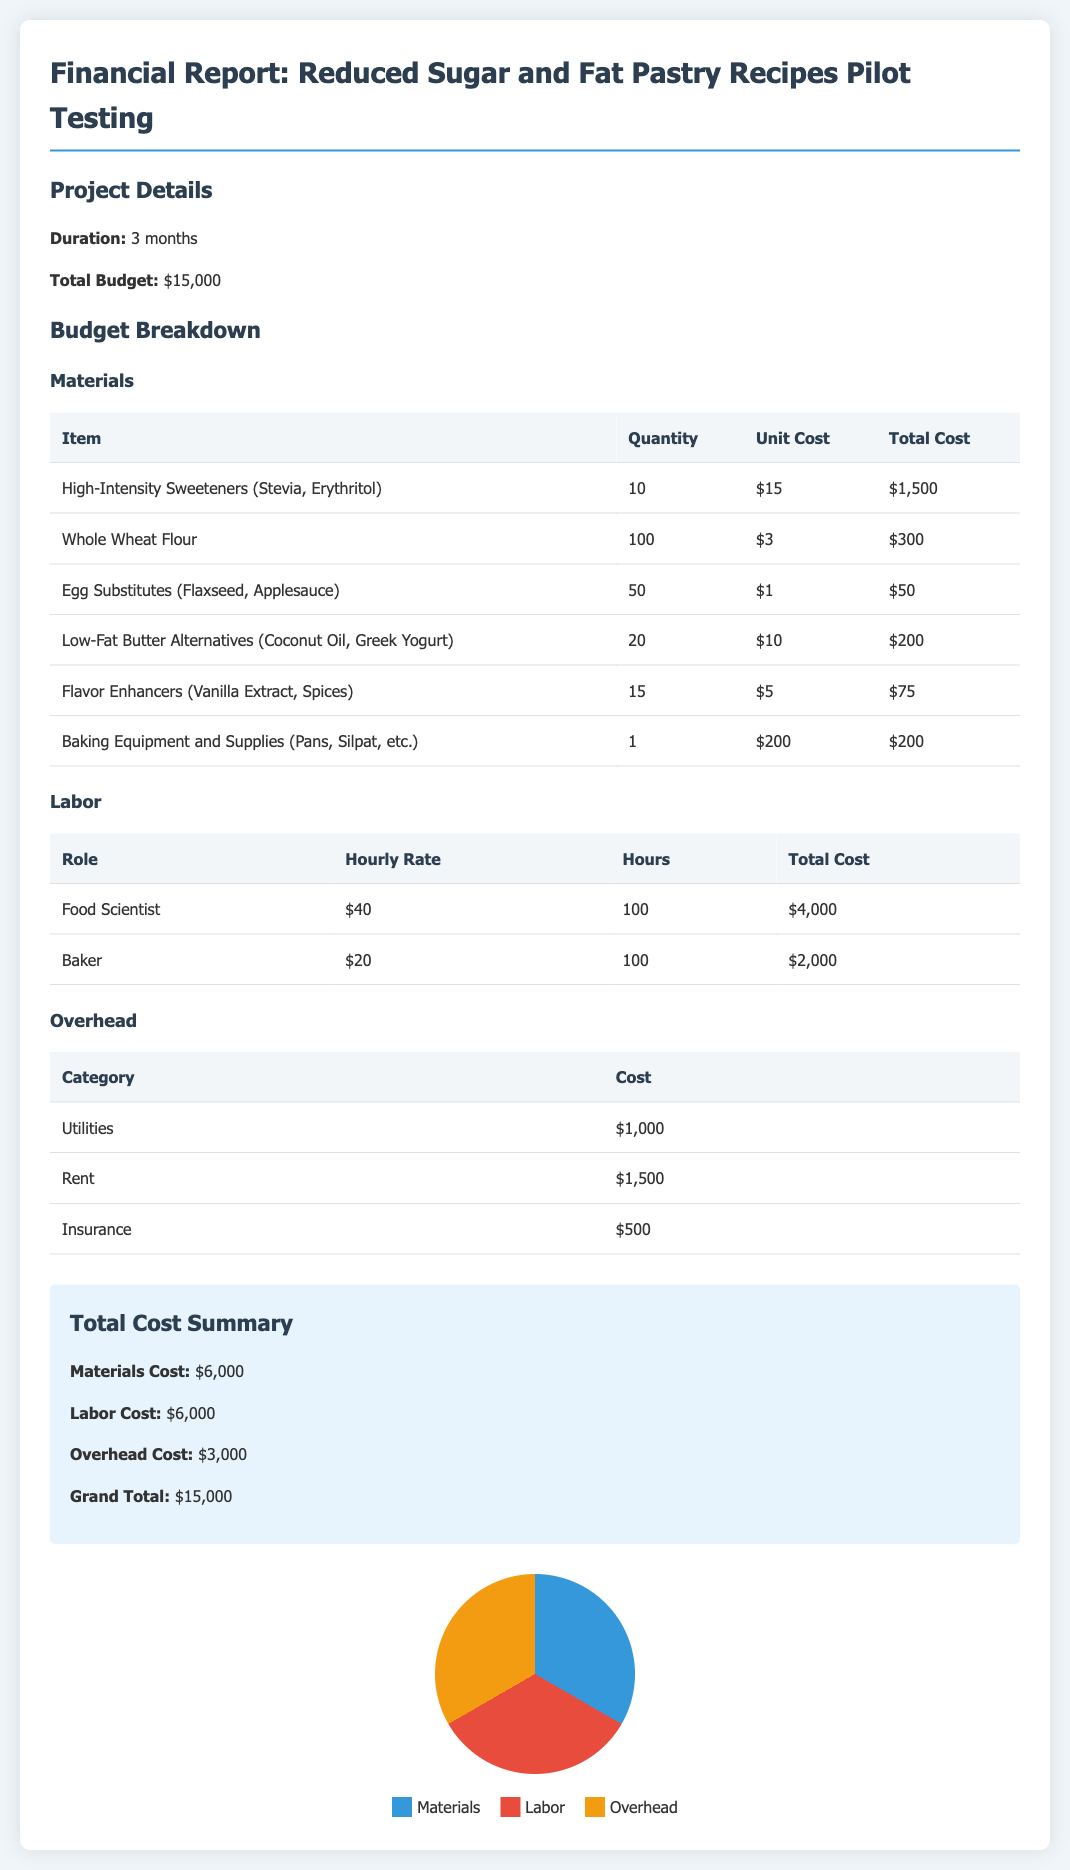What is the total budget for the pilot testing? The total budget is explicitly stated in the document as the overall funding allocated for pilot testing.
Answer: $15,000 How long is the pilot testing scheduled to last? The duration of the pilot testing is mentioned directly in the document under project details.
Answer: 3 months What is the total cost for labor? The total cost for labor is provided as part of the budget breakdown section, reflecting the sum of all labor-related expenses.
Answer: $6,000 What is the unit cost for high-intensity sweeteners? The document lists the unit cost for high-intensity sweeteners as a specific line item under materials costs.
Answer: $15 How much was allocated for utilities as part of the overhead? The cost allocation for utilities is clearly outlined in the overhead cost table within the document.
Answer: $1,000 Which two roles have associated labor costs in the report? The document specifies the roles contributing to labor costs within its labor cost section, indicating which personnel are involved.
Answer: Food Scientist, Baker What percentage of the total budget is designated for materials? To find this percentage, you calculate the materials cost as a fraction of the total budget, as reflected in the financial report.
Answer: 40% What is the total cost associated with flavor enhancers? The document provides a breakdown of costs per item listed, allowing you to directly find the total for flavor enhancers.
Answer: $75 What kind of baking equipment is listed in the materials section? The document specifically names the type of baking equipment detailed in the materials section of the report.
Answer: Pans, Silpat, etc 